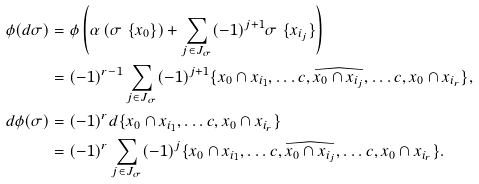<formula> <loc_0><loc_0><loc_500><loc_500>\phi ( d \sigma ) & = \phi \left ( \alpha \left ( \sigma \ \{ x _ { 0 } \} \right ) + \sum _ { j \in J _ { \sigma } } ( - 1 ) ^ { j + 1 } \sigma \ \{ x _ { i _ { j } } \} \right ) \\ & = ( - 1 ) ^ { r - 1 } \sum _ { j \in J _ { \sigma } } ( - 1 ) ^ { j + 1 } \{ x _ { 0 } \cap x _ { i _ { 1 } } , \dots c , \widehat { x _ { 0 } \cap x _ { i _ { j } } } , \dots c , x _ { 0 } \cap x _ { i _ { r } } \} , \\ d \phi ( \sigma ) & = ( - 1 ) ^ { r } d \{ x _ { 0 } \cap x _ { i _ { 1 } } , \dots c , x _ { 0 } \cap x _ { i _ { r } } \} \\ & = ( - 1 ) ^ { r } \sum _ { j \in J _ { \sigma } } ( - 1 ) ^ { j } \{ x _ { 0 } \cap x _ { i _ { 1 } } , \dots c , \widehat { x _ { 0 } \cap x _ { i _ { j } } } , \dots c , x _ { 0 } \cap x _ { i _ { r } } \} .</formula> 